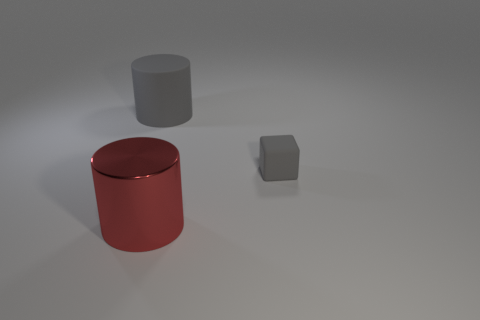What is the material of the cylinder that is the same color as the small cube?
Give a very brief answer. Rubber. What is the color of the tiny thing?
Make the answer very short. Gray. How many cyan matte cubes are there?
Provide a short and direct response. 0. Is the red cylinder made of the same material as the gray thing to the right of the big gray matte cylinder?
Make the answer very short. No. Does the object that is in front of the gray rubber block have the same color as the tiny thing?
Your answer should be very brief. No. There is a thing that is both behind the shiny cylinder and in front of the large gray matte cylinder; what material is it?
Keep it short and to the point. Rubber. What size is the red cylinder?
Offer a terse response. Large. There is a big matte object; is it the same color as the object that is to the right of the metal object?
Your response must be concise. Yes. What number of other objects are there of the same color as the shiny object?
Your answer should be very brief. 0. Is the size of the matte object that is right of the large matte cylinder the same as the gray rubber thing on the left side of the red shiny cylinder?
Your response must be concise. No. 